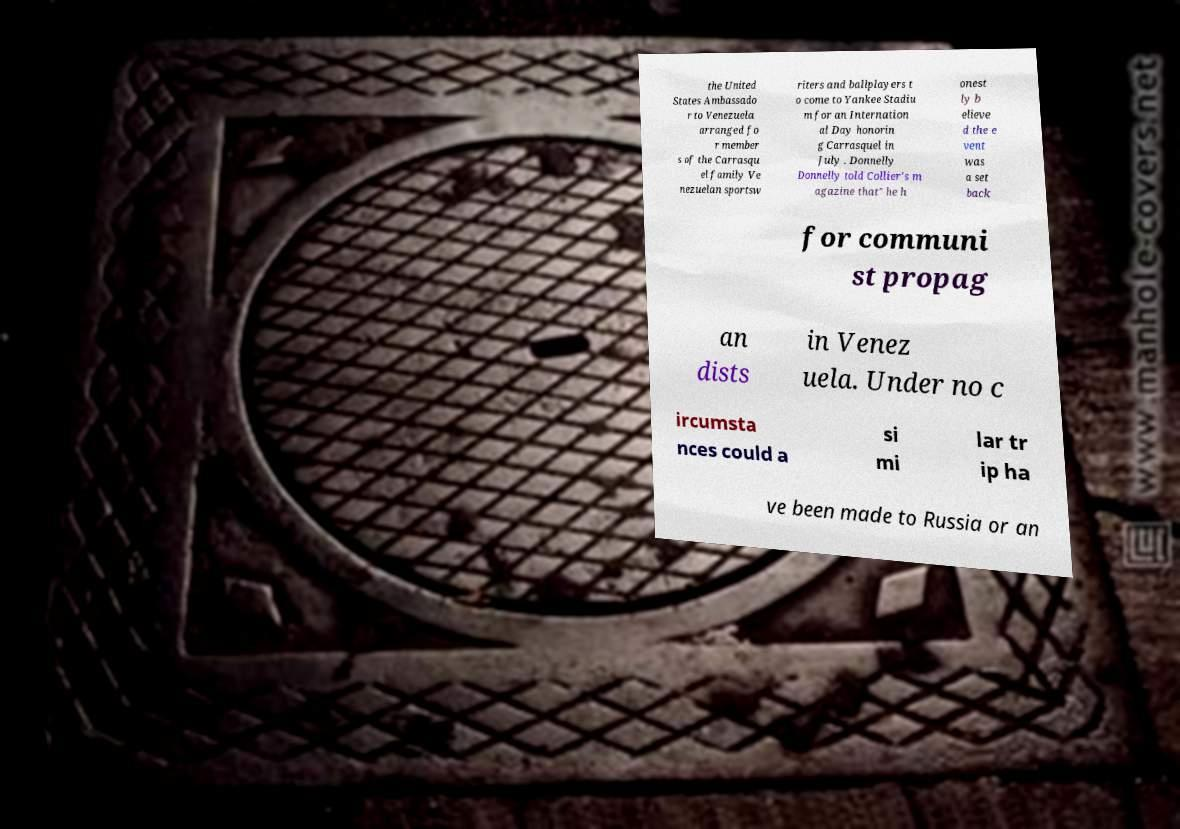Could you extract and type out the text from this image? the United States Ambassado r to Venezuela arranged fo r member s of the Carrasqu el family Ve nezuelan sportsw riters and ballplayers t o come to Yankee Stadiu m for an Internation al Day honorin g Carrasquel in July . Donnelly Donnelly told Collier's m agazine that" he h onest ly b elieve d the e vent was a set back for communi st propag an dists in Venez uela. Under no c ircumsta nces could a si mi lar tr ip ha ve been made to Russia or an 